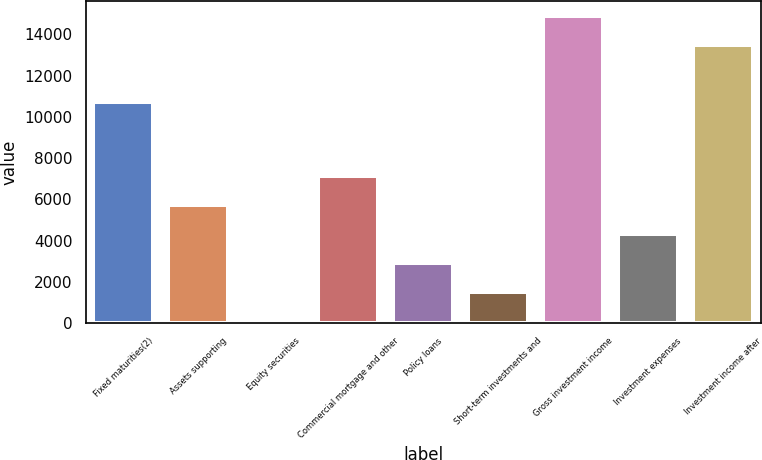Convert chart. <chart><loc_0><loc_0><loc_500><loc_500><bar_chart><fcel>Fixed maturities(2)<fcel>Assets supporting<fcel>Equity securities<fcel>Commercial mortgage and other<fcel>Policy loans<fcel>Short-term investments and<fcel>Gross investment income<fcel>Investment expenses<fcel>Investment income after<nl><fcel>10711<fcel>5724<fcel>120<fcel>7125<fcel>2922<fcel>1521<fcel>14897<fcel>4323<fcel>13496<nl></chart> 